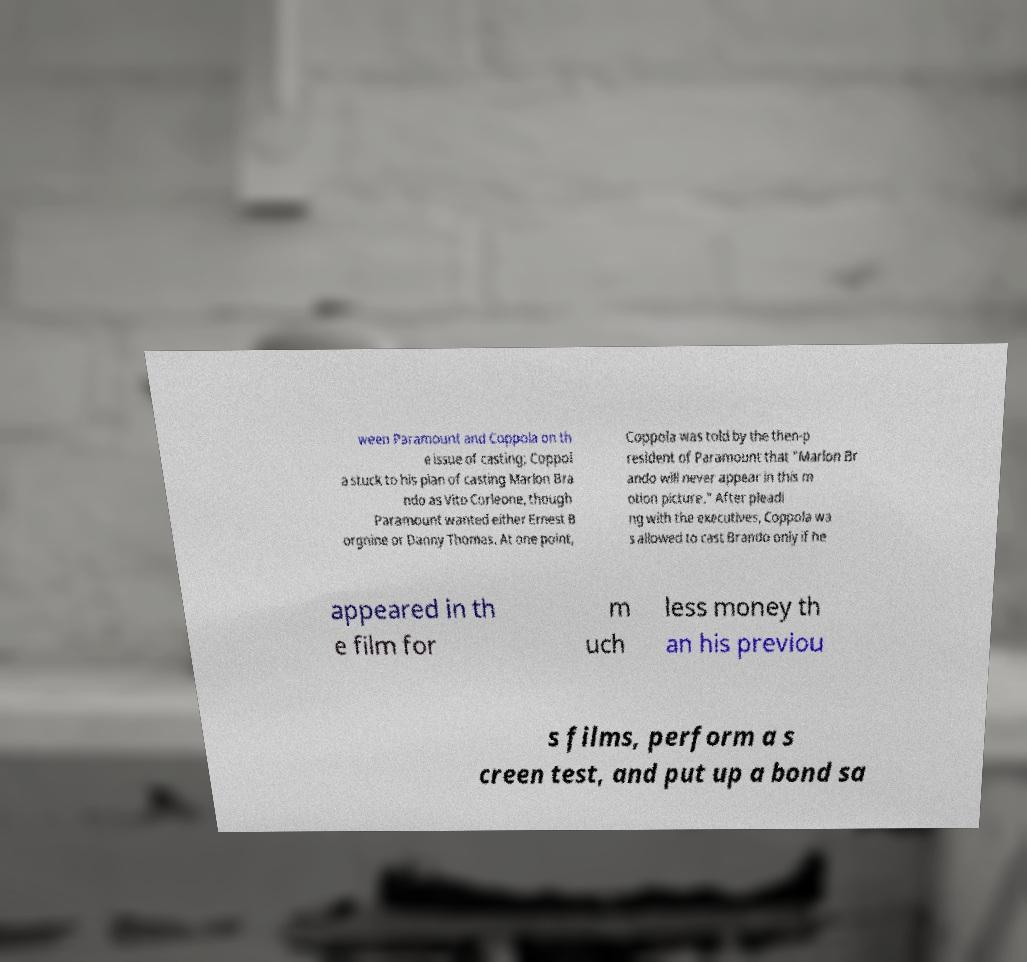There's text embedded in this image that I need extracted. Can you transcribe it verbatim? ween Paramount and Coppola on th e issue of casting; Coppol a stuck to his plan of casting Marlon Bra ndo as Vito Corleone, though Paramount wanted either Ernest B orgnine or Danny Thomas. At one point, Coppola was told by the then-p resident of Paramount that "Marlon Br ando will never appear in this m otion picture." After pleadi ng with the executives, Coppola wa s allowed to cast Brando only if he appeared in th e film for m uch less money th an his previou s films, perform a s creen test, and put up a bond sa 